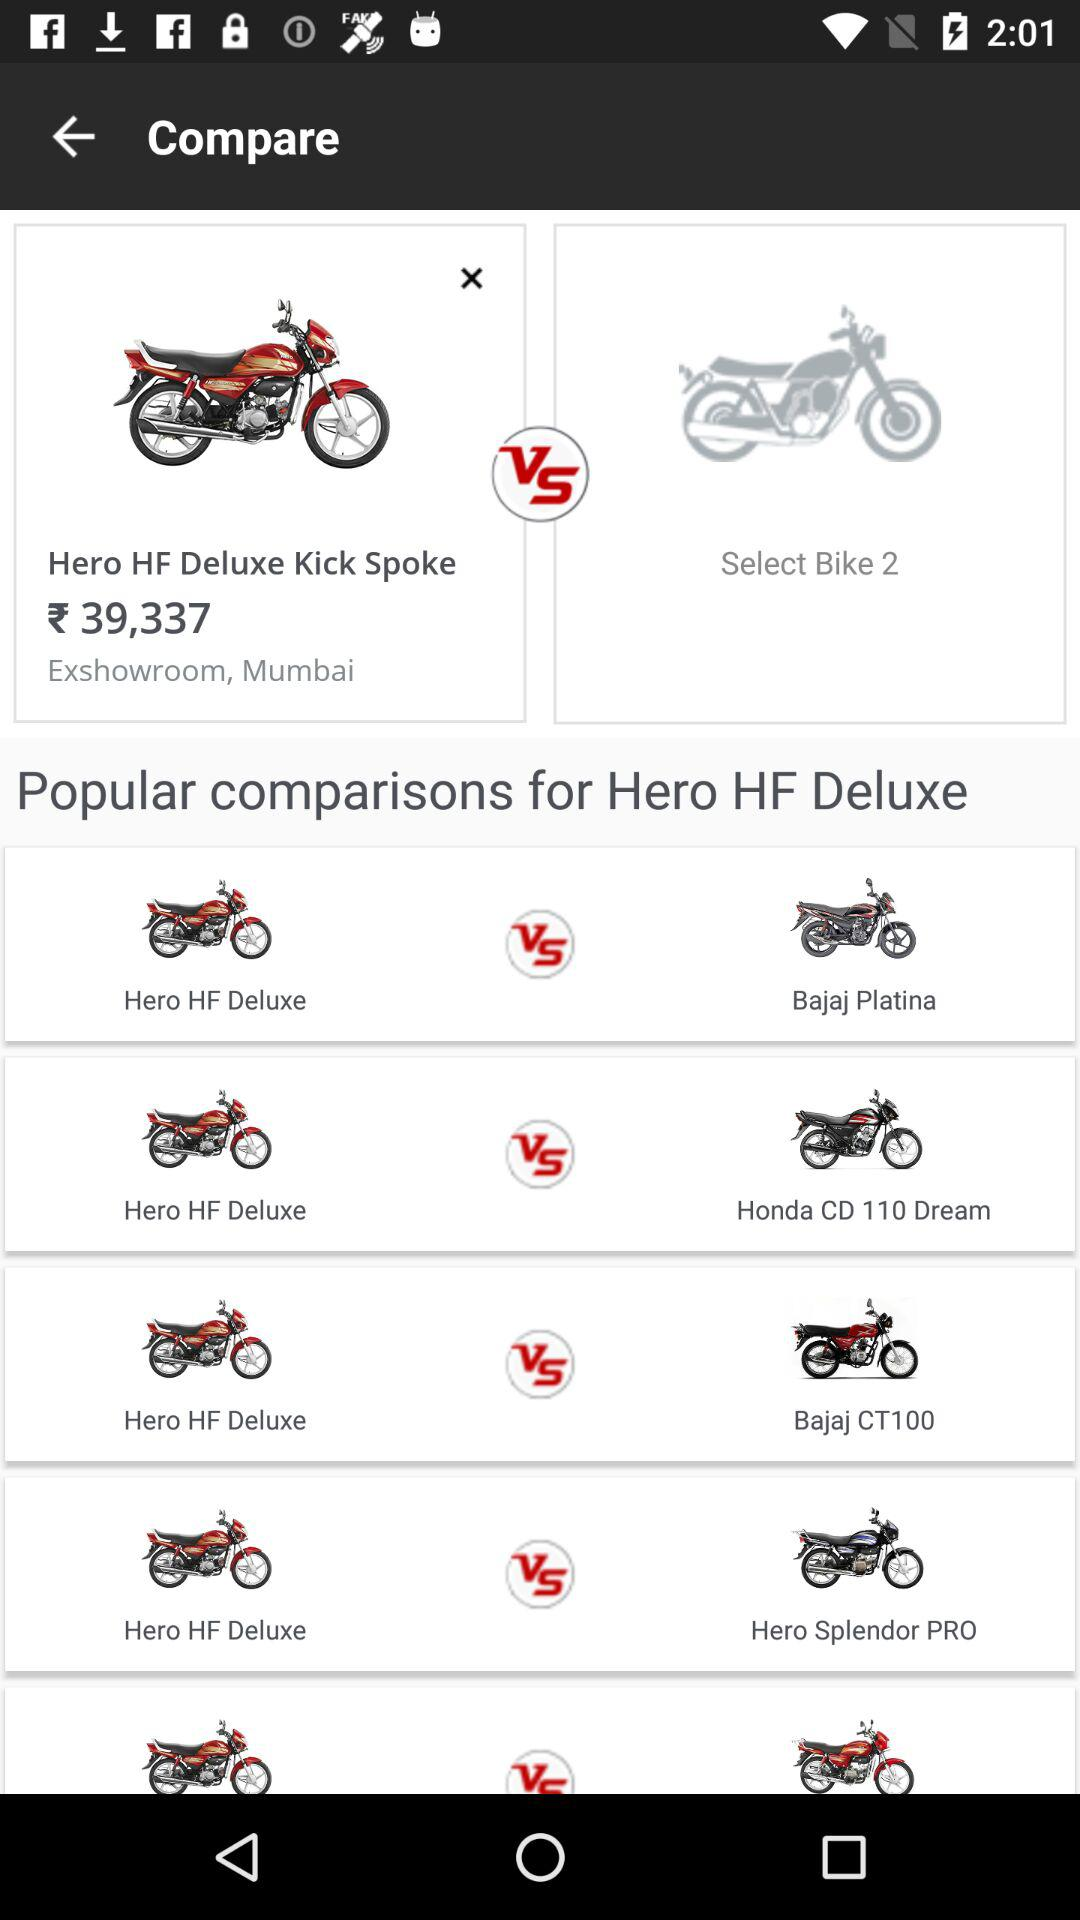What are the bike names in the comparison? The bike names in the comparison are "Hero HF Deluxe Kick Spoke", "Bajaj Platina", "Honda CD 110 Dream", "Bajaj CT100" and "Hero Splendor PRO". 